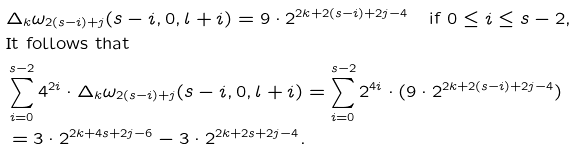<formula> <loc_0><loc_0><loc_500><loc_500>& \Delta _ { k } \omega _ { 2 ( s - i ) + j } ( s - i , 0 , l + i ) = 9 \cdot 2 ^ { 2 k + 2 ( s - i ) + 2 j - 4 } \quad \text {if $ 0\leq i\leq s -2 $} , \\ & \text {It follows that} \\ & \sum _ { i = 0 } ^ { s - 2 } 4 ^ { 2 i } \cdot \Delta _ { k } \omega _ { 2 ( s - i ) + j } ( s - i , 0 , l + i ) = \sum _ { i = 0 } ^ { s - 2 } 2 ^ { 4 i } \cdot ( 9 \cdot 2 ^ { 2 k + 2 ( s - i ) + 2 j - 4 } ) \\ & = 3 \cdot 2 ^ { 2 k + 4 s + 2 j - 6 } - 3 \cdot 2 ^ { 2 k + 2 s + 2 j - 4 } .</formula> 